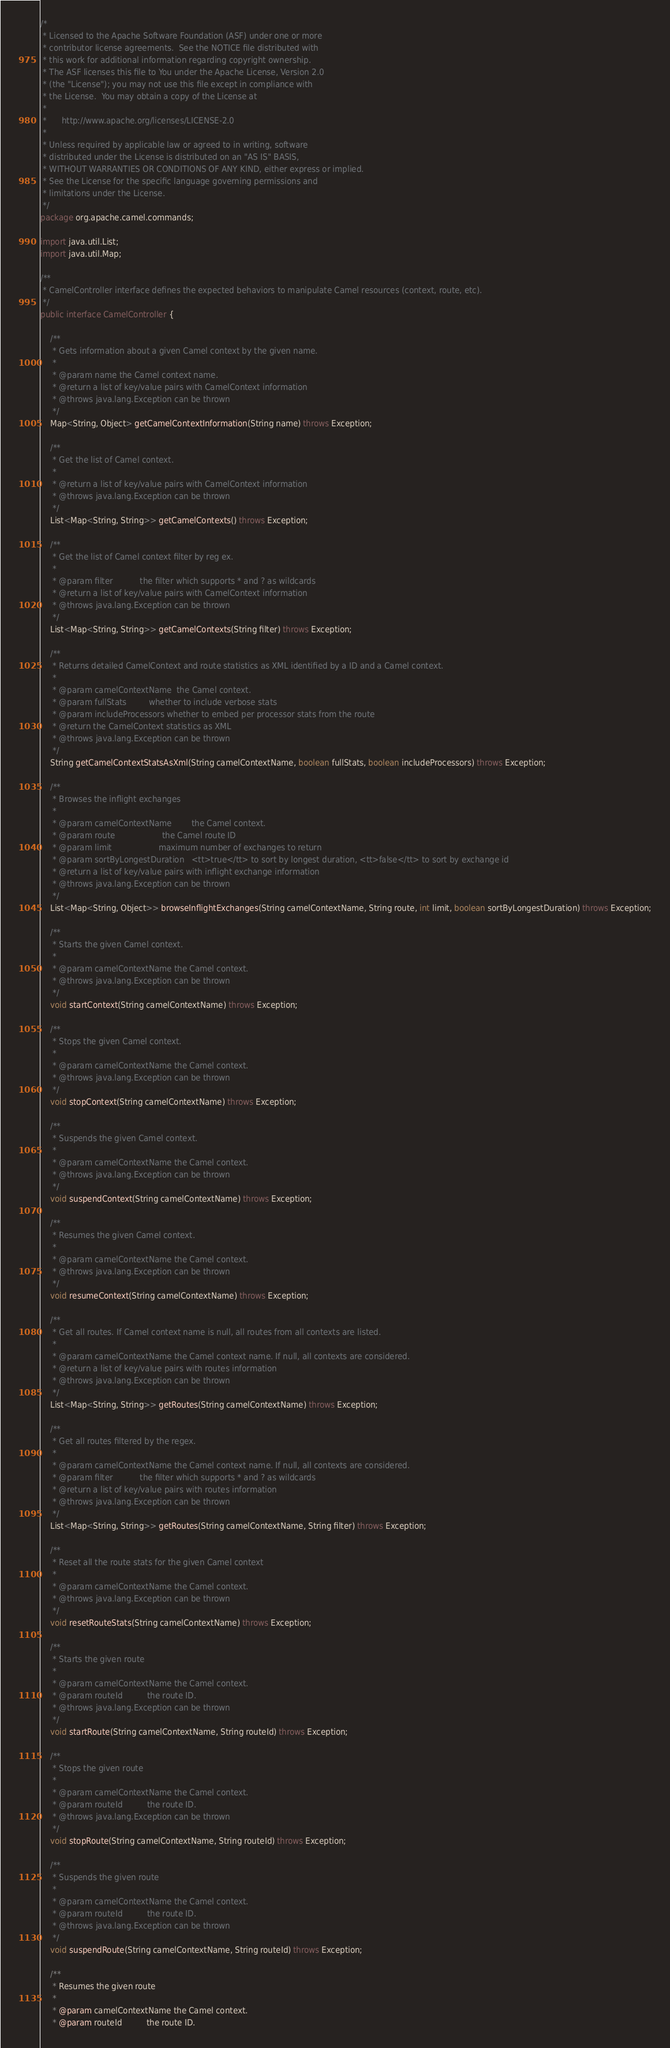Convert code to text. <code><loc_0><loc_0><loc_500><loc_500><_Java_>/*
 * Licensed to the Apache Software Foundation (ASF) under one or more
 * contributor license agreements.  See the NOTICE file distributed with
 * this work for additional information regarding copyright ownership.
 * The ASF licenses this file to You under the Apache License, Version 2.0
 * (the "License"); you may not use this file except in compliance with
 * the License.  You may obtain a copy of the License at
 *
 *      http://www.apache.org/licenses/LICENSE-2.0
 *
 * Unless required by applicable law or agreed to in writing, software
 * distributed under the License is distributed on an "AS IS" BASIS,
 * WITHOUT WARRANTIES OR CONDITIONS OF ANY KIND, either express or implied.
 * See the License for the specific language governing permissions and
 * limitations under the License.
 */
package org.apache.camel.commands;

import java.util.List;
import java.util.Map;

/**
 * CamelController interface defines the expected behaviors to manipulate Camel resources (context, route, etc).
 */
public interface CamelController {

    /**
     * Gets information about a given Camel context by the given name.
     *
     * @param name the Camel context name.
     * @return a list of key/value pairs with CamelContext information
     * @throws java.lang.Exception can be thrown
     */
    Map<String, Object> getCamelContextInformation(String name) throws Exception;

    /**
     * Get the list of Camel context.
     *
     * @return a list of key/value pairs with CamelContext information
     * @throws java.lang.Exception can be thrown
     */
    List<Map<String, String>> getCamelContexts() throws Exception;

    /**
     * Get the list of Camel context filter by reg ex.
     *
     * @param filter           the filter which supports * and ? as wildcards
     * @return a list of key/value pairs with CamelContext information
     * @throws java.lang.Exception can be thrown
     */
    List<Map<String, String>> getCamelContexts(String filter) throws Exception;

    /**
     * Returns detailed CamelContext and route statistics as XML identified by a ID and a Camel context.
     *
     * @param camelContextName  the Camel context.
     * @param fullStats         whether to include verbose stats
     * @param includeProcessors whether to embed per processor stats from the route
     * @return the CamelContext statistics as XML
     * @throws java.lang.Exception can be thrown
     */
    String getCamelContextStatsAsXml(String camelContextName, boolean fullStats, boolean includeProcessors) throws Exception;

    /**
     * Browses the inflight exchanges
     *
     * @param camelContextName        the Camel context.
     * @param route                   the Camel route ID
     * @param limit                   maximum number of exchanges to return
     * @param sortByLongestDuration   <tt>true</tt> to sort by longest duration, <tt>false</tt> to sort by exchange id
     * @return a list of key/value pairs with inflight exchange information
     * @throws java.lang.Exception can be thrown
     */
    List<Map<String, Object>> browseInflightExchanges(String camelContextName, String route, int limit, boolean sortByLongestDuration) throws Exception;

    /**
     * Starts the given Camel context.
     *
     * @param camelContextName the Camel context.
     * @throws java.lang.Exception can be thrown
     */
    void startContext(String camelContextName) throws Exception;

    /**
     * Stops the given Camel context.
     *
     * @param camelContextName the Camel context.
     * @throws java.lang.Exception can be thrown
     */
    void stopContext(String camelContextName) throws Exception;

    /**
     * Suspends the given Camel context.
     *
     * @param camelContextName the Camel context.
     * @throws java.lang.Exception can be thrown
     */
    void suspendContext(String camelContextName) throws Exception;

    /**
     * Resumes the given Camel context.
     *
     * @param camelContextName the Camel context.
     * @throws java.lang.Exception can be thrown
     */
    void resumeContext(String camelContextName) throws Exception;

    /**
     * Get all routes. If Camel context name is null, all routes from all contexts are listed.
     *
     * @param camelContextName the Camel context name. If null, all contexts are considered.
     * @return a list of key/value pairs with routes information
     * @throws java.lang.Exception can be thrown
     */
    List<Map<String, String>> getRoutes(String camelContextName) throws Exception;

    /**
     * Get all routes filtered by the regex.
     *
     * @param camelContextName the Camel context name. If null, all contexts are considered.
     * @param filter           the filter which supports * and ? as wildcards
     * @return a list of key/value pairs with routes information
     * @throws java.lang.Exception can be thrown
     */
    List<Map<String, String>> getRoutes(String camelContextName, String filter) throws Exception;

    /**
     * Reset all the route stats for the given Camel context
     *
     * @param camelContextName the Camel context.
     * @throws java.lang.Exception can be thrown
     */
    void resetRouteStats(String camelContextName) throws Exception;

    /**
     * Starts the given route
     *
     * @param camelContextName the Camel context.
     * @param routeId          the route ID.
     * @throws java.lang.Exception can be thrown
     */
    void startRoute(String camelContextName, String routeId) throws Exception;

    /**
     * Stops the given route
     *
     * @param camelContextName the Camel context.
     * @param routeId          the route ID.
     * @throws java.lang.Exception can be thrown
     */
    void stopRoute(String camelContextName, String routeId) throws Exception;

    /**
     * Suspends the given route
     *
     * @param camelContextName the Camel context.
     * @param routeId          the route ID.
     * @throws java.lang.Exception can be thrown
     */
    void suspendRoute(String camelContextName, String routeId) throws Exception;

    /**
     * Resumes the given route
     *
     * @param camelContextName the Camel context.
     * @param routeId          the route ID.</code> 